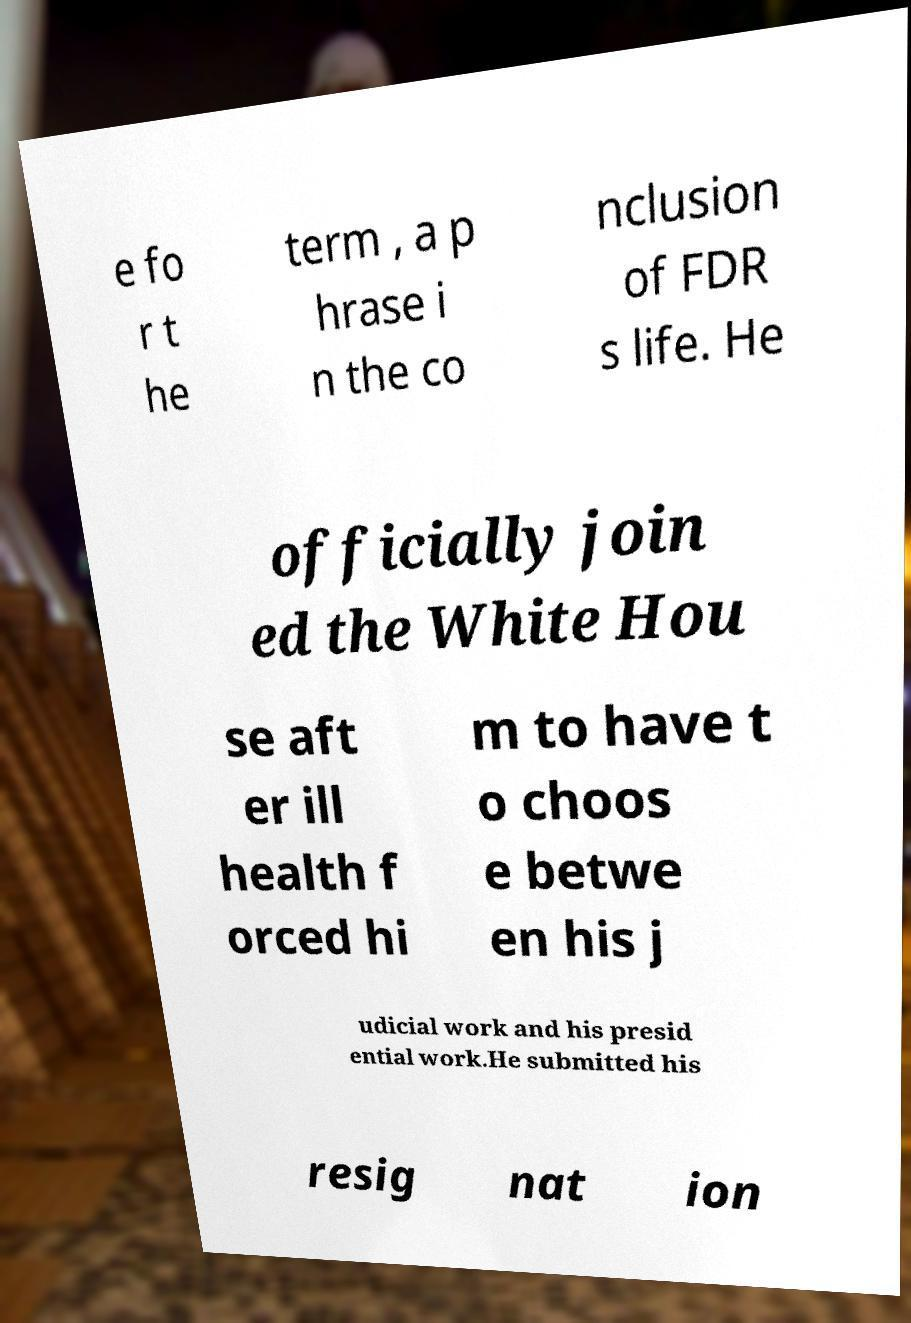For documentation purposes, I need the text within this image transcribed. Could you provide that? e fo r t he term , a p hrase i n the co nclusion of FDR s life. He officially join ed the White Hou se aft er ill health f orced hi m to have t o choos e betwe en his j udicial work and his presid ential work.He submitted his resig nat ion 